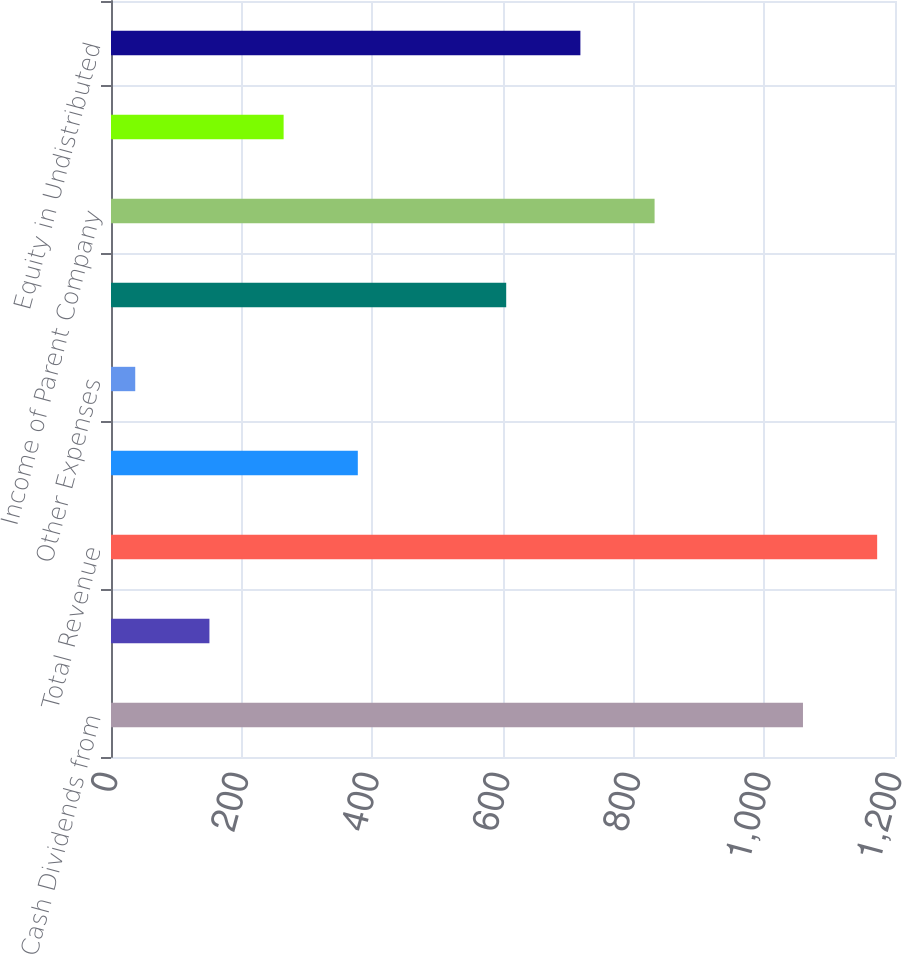Convert chart. <chart><loc_0><loc_0><loc_500><loc_500><bar_chart><fcel>Cash Dividends from<fcel>Other Income<fcel>Total Revenue<fcel>Interest and Debt Expense<fcel>Other Expenses<fcel>Total Expenses<fcel>Income of Parent Company<fcel>Income Tax Expense (Benefit)<fcel>Equity in Undistributed<nl><fcel>1059.14<fcel>150.66<fcel>1172.7<fcel>377.78<fcel>37.1<fcel>604.9<fcel>832.02<fcel>264.22<fcel>718.46<nl></chart> 